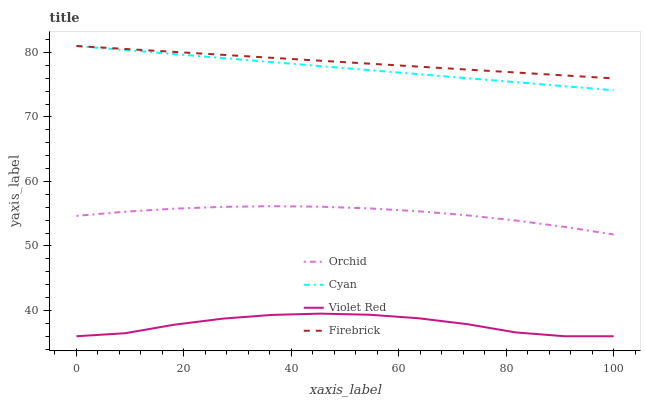Does Violet Red have the minimum area under the curve?
Answer yes or no. Yes. Does Firebrick have the maximum area under the curve?
Answer yes or no. Yes. Does Firebrick have the minimum area under the curve?
Answer yes or no. No. Does Violet Red have the maximum area under the curve?
Answer yes or no. No. Is Cyan the smoothest?
Answer yes or no. Yes. Is Violet Red the roughest?
Answer yes or no. Yes. Is Firebrick the smoothest?
Answer yes or no. No. Is Firebrick the roughest?
Answer yes or no. No. Does Violet Red have the lowest value?
Answer yes or no. Yes. Does Firebrick have the lowest value?
Answer yes or no. No. Does Firebrick have the highest value?
Answer yes or no. Yes. Does Violet Red have the highest value?
Answer yes or no. No. Is Violet Red less than Cyan?
Answer yes or no. Yes. Is Firebrick greater than Orchid?
Answer yes or no. Yes. Does Firebrick intersect Cyan?
Answer yes or no. Yes. Is Firebrick less than Cyan?
Answer yes or no. No. Is Firebrick greater than Cyan?
Answer yes or no. No. Does Violet Red intersect Cyan?
Answer yes or no. No. 